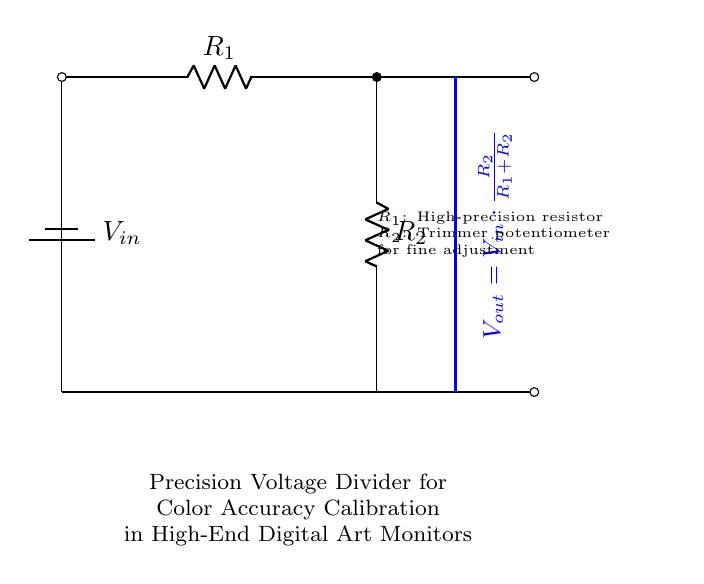What is the input voltage of the circuit? The input voltage is marked as V_in at the top of the circuit diagram. It represents the total voltage supplied to the voltage divider.
Answer: V_in What components are used in this voltage divider? The circuit diagram shows a battery (representing input voltage), two resistors (R_1 and R_2), and a trimmer potentiometer for fine adjustment.
Answer: Battery, R_1, R_2 What is the role of the trimmer potentiometer? The trimmer potentiometer (R_2) is used for fine adjustment of the output voltage in the voltage divider setup, allowing precise calibration.
Answer: Fine adjustment What is the output voltage formula represented in the circuit? The formula for output voltage is V_out = V_in * (R_2 / (R_1 + R_2)), which shows how the output voltage is derived from the resistor values and input voltage.
Answer: V_out = V_in * (R_2 / (R_1 + R_2)) If R_1 is a high-precision resistor, why is R_2 adjustable? R_1 is fixed for stability and precision, while R_2 is adjustable to fine-tune the output voltage, essential for accurate color calibration in monitors.
Answer: For calibration What does a higher resistance value in R_2 indicate for output voltage? A higher resistance value in R_2 increases the proportion of V_out relative to V_in, resulting in a higher output voltage.
Answer: Higher output voltage How would you describe the overall purpose of this circuit? The main purpose of this circuit is to accurately divide an input voltage to obtain a specific output voltage necessary for calibrating color accuracy in high-end monitors used by digital artists.
Answer: Color accuracy calibration 